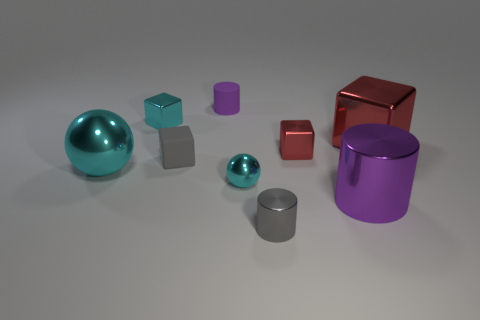Subtract all cyan cubes. How many cubes are left? 3 Subtract all shiny cylinders. How many cylinders are left? 1 Add 1 large purple objects. How many objects exist? 10 Subtract 2 balls. How many balls are left? 0 Subtract all cyan cubes. Subtract all brown cylinders. How many cubes are left? 3 Subtract all red blocks. How many red cylinders are left? 0 Subtract all cubes. How many objects are left? 5 Subtract all small brown cubes. Subtract all large shiny balls. How many objects are left? 8 Add 7 large objects. How many large objects are left? 10 Add 8 purple metal things. How many purple metal things exist? 9 